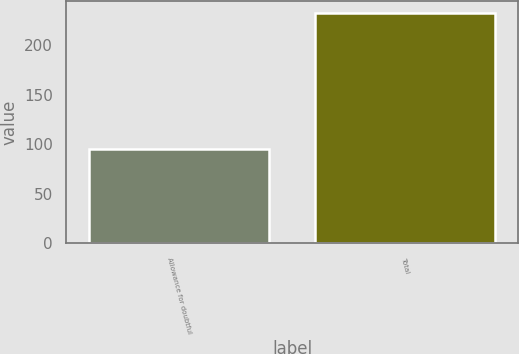Convert chart. <chart><loc_0><loc_0><loc_500><loc_500><bar_chart><fcel>Allowance for doubtful<fcel>Total<nl><fcel>95<fcel>233<nl></chart> 